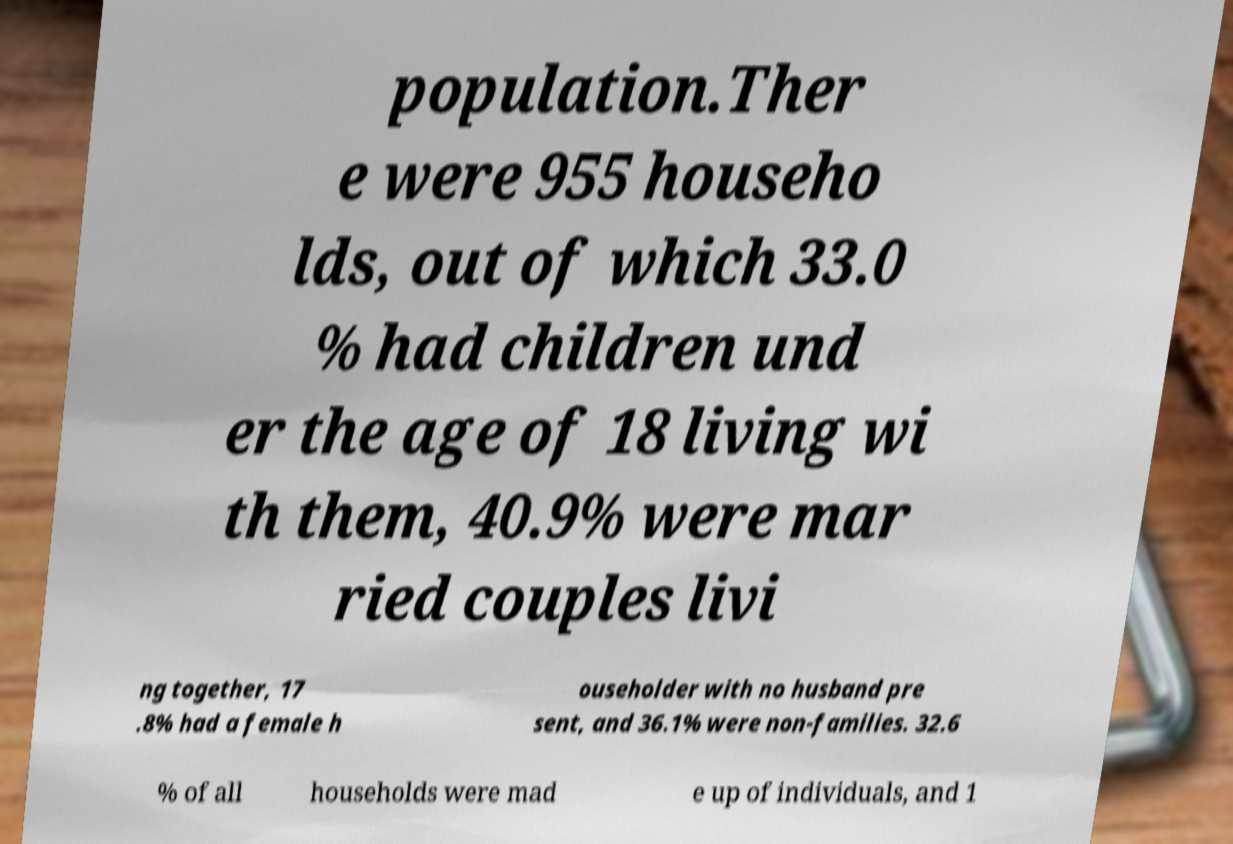Could you extract and type out the text from this image? population.Ther e were 955 househo lds, out of which 33.0 % had children und er the age of 18 living wi th them, 40.9% were mar ried couples livi ng together, 17 .8% had a female h ouseholder with no husband pre sent, and 36.1% were non-families. 32.6 % of all households were mad e up of individuals, and 1 